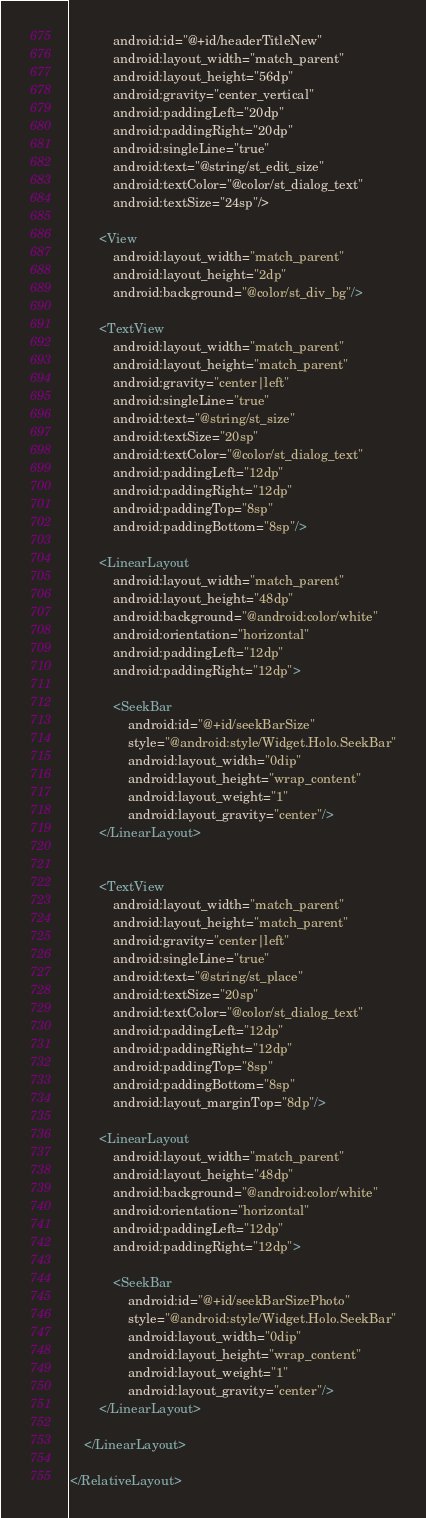Convert code to text. <code><loc_0><loc_0><loc_500><loc_500><_XML_>            android:id="@+id/headerTitleNew"
            android:layout_width="match_parent"
            android:layout_height="56dp"
            android:gravity="center_vertical"
            android:paddingLeft="20dp"
            android:paddingRight="20dp"
            android:singleLine="true"
            android:text="@string/st_edit_size"
            android:textColor="@color/st_dialog_text"
            android:textSize="24sp"/>

        <View
            android:layout_width="match_parent"
            android:layout_height="2dp"
            android:background="@color/st_div_bg"/>

        <TextView
            android:layout_width="match_parent"
            android:layout_height="match_parent"
            android:gravity="center|left"
            android:singleLine="true"
            android:text="@string/st_size"
            android:textSize="20sp"
            android:textColor="@color/st_dialog_text"
            android:paddingLeft="12dp"
            android:paddingRight="12dp"
            android:paddingTop="8sp"
            android:paddingBottom="8sp"/>

        <LinearLayout
            android:layout_width="match_parent"
            android:layout_height="48dp"
            android:background="@android:color/white"
            android:orientation="horizontal"
            android:paddingLeft="12dp"
            android:paddingRight="12dp">

            <SeekBar
                android:id="@+id/seekBarSize"
                style="@android:style/Widget.Holo.SeekBar"
                android:layout_width="0dip"
                android:layout_height="wrap_content"
                android:layout_weight="1"
                android:layout_gravity="center"/>
        </LinearLayout>


        <TextView
            android:layout_width="match_parent"
            android:layout_height="match_parent"
            android:gravity="center|left"
            android:singleLine="true"
            android:text="@string/st_place"
            android:textSize="20sp"
            android:textColor="@color/st_dialog_text"
            android:paddingLeft="12dp"
            android:paddingRight="12dp"
            android:paddingTop="8sp"
            android:paddingBottom="8sp"
            android:layout_marginTop="8dp"/>

        <LinearLayout
            android:layout_width="match_parent"
            android:layout_height="48dp"
            android:background="@android:color/white"
            android:orientation="horizontal"
            android:paddingLeft="12dp"
            android:paddingRight="12dp">

            <SeekBar
                android:id="@+id/seekBarSizePhoto"
                style="@android:style/Widget.Holo.SeekBar"
                android:layout_width="0dip"
                android:layout_height="wrap_content"
                android:layout_weight="1"
                android:layout_gravity="center"/>
        </LinearLayout>

    </LinearLayout>

</RelativeLayout></code> 